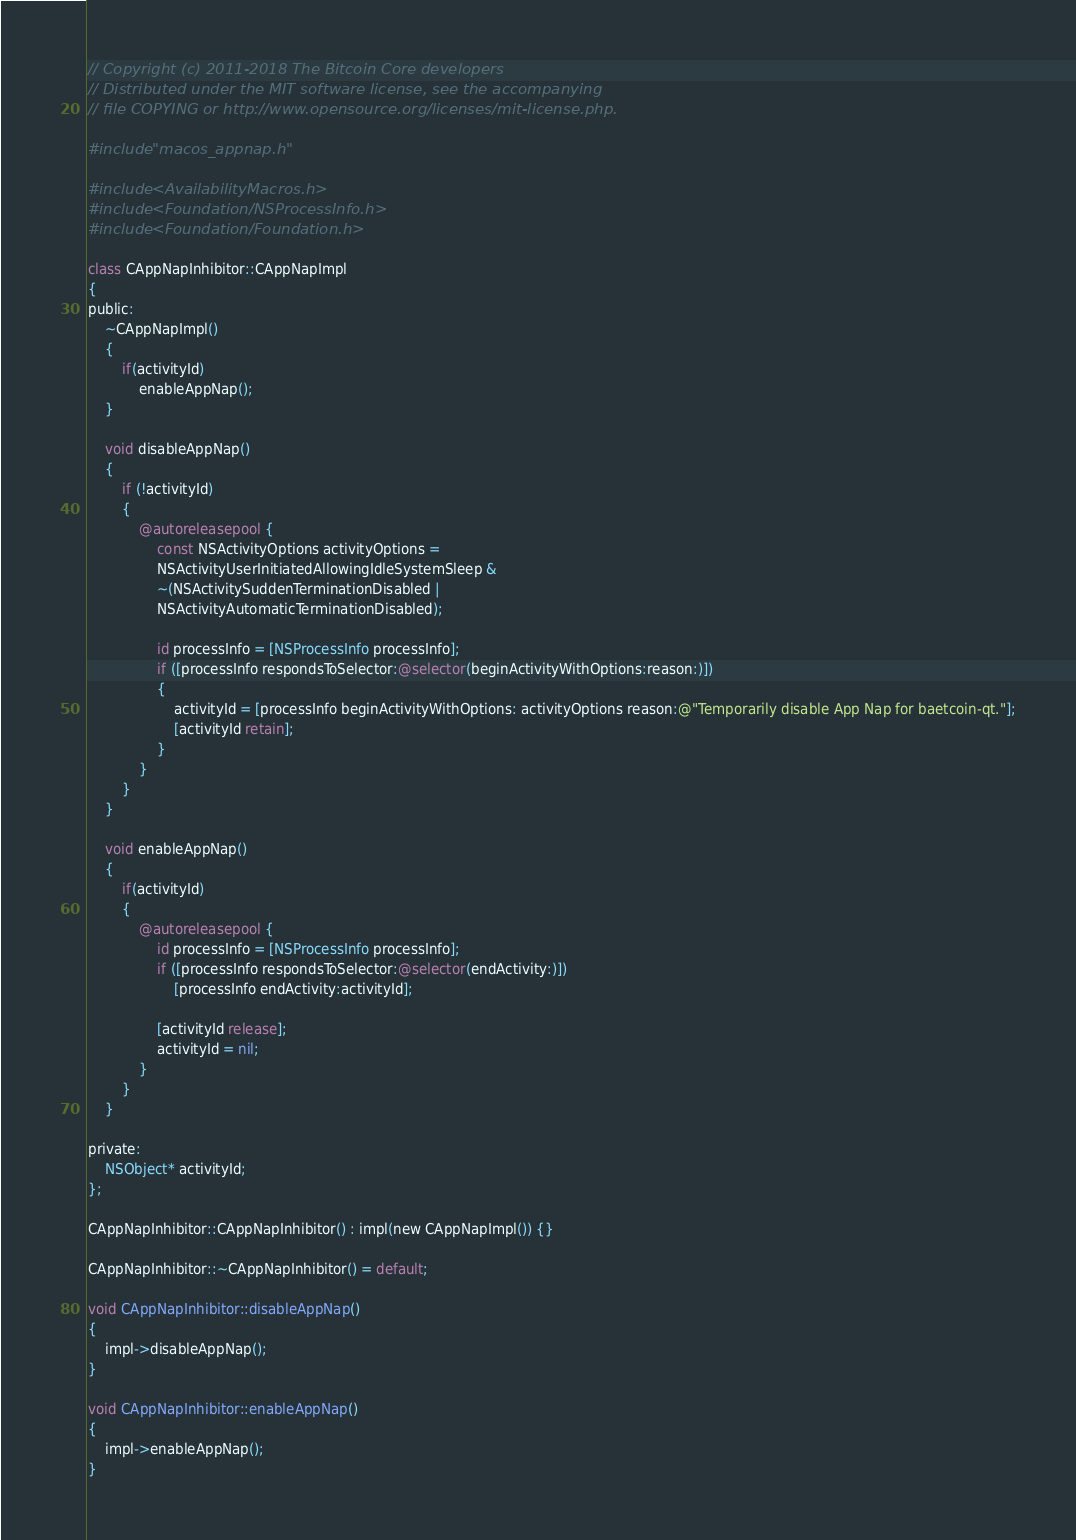<code> <loc_0><loc_0><loc_500><loc_500><_ObjectiveC_>// Copyright (c) 2011-2018 The Bitcoin Core developers
// Distributed under the MIT software license, see the accompanying
// file COPYING or http://www.opensource.org/licenses/mit-license.php.

#include "macos_appnap.h"

#include <AvailabilityMacros.h>
#include <Foundation/NSProcessInfo.h>
#include <Foundation/Foundation.h>

class CAppNapInhibitor::CAppNapImpl
{
public:
    ~CAppNapImpl()
    {
        if(activityId)
            enableAppNap();
    }

    void disableAppNap()
    {
        if (!activityId)
        {
            @autoreleasepool {
                const NSActivityOptions activityOptions =
                NSActivityUserInitiatedAllowingIdleSystemSleep &
                ~(NSActivitySuddenTerminationDisabled |
                NSActivityAutomaticTerminationDisabled);

                id processInfo = [NSProcessInfo processInfo];
                if ([processInfo respondsToSelector:@selector(beginActivityWithOptions:reason:)])
                {
                    activityId = [processInfo beginActivityWithOptions: activityOptions reason:@"Temporarily disable App Nap for baetcoin-qt."];
                    [activityId retain];
                }
            }
        }
    }

    void enableAppNap()
    {
        if(activityId)
        {
            @autoreleasepool {
                id processInfo = [NSProcessInfo processInfo];
                if ([processInfo respondsToSelector:@selector(endActivity:)])
                    [processInfo endActivity:activityId];

                [activityId release];
                activityId = nil;
            }
        }
    }

private:
    NSObject* activityId;
};

CAppNapInhibitor::CAppNapInhibitor() : impl(new CAppNapImpl()) {}

CAppNapInhibitor::~CAppNapInhibitor() = default;

void CAppNapInhibitor::disableAppNap()
{
    impl->disableAppNap();
}

void CAppNapInhibitor::enableAppNap()
{
    impl->enableAppNap();
}
</code> 